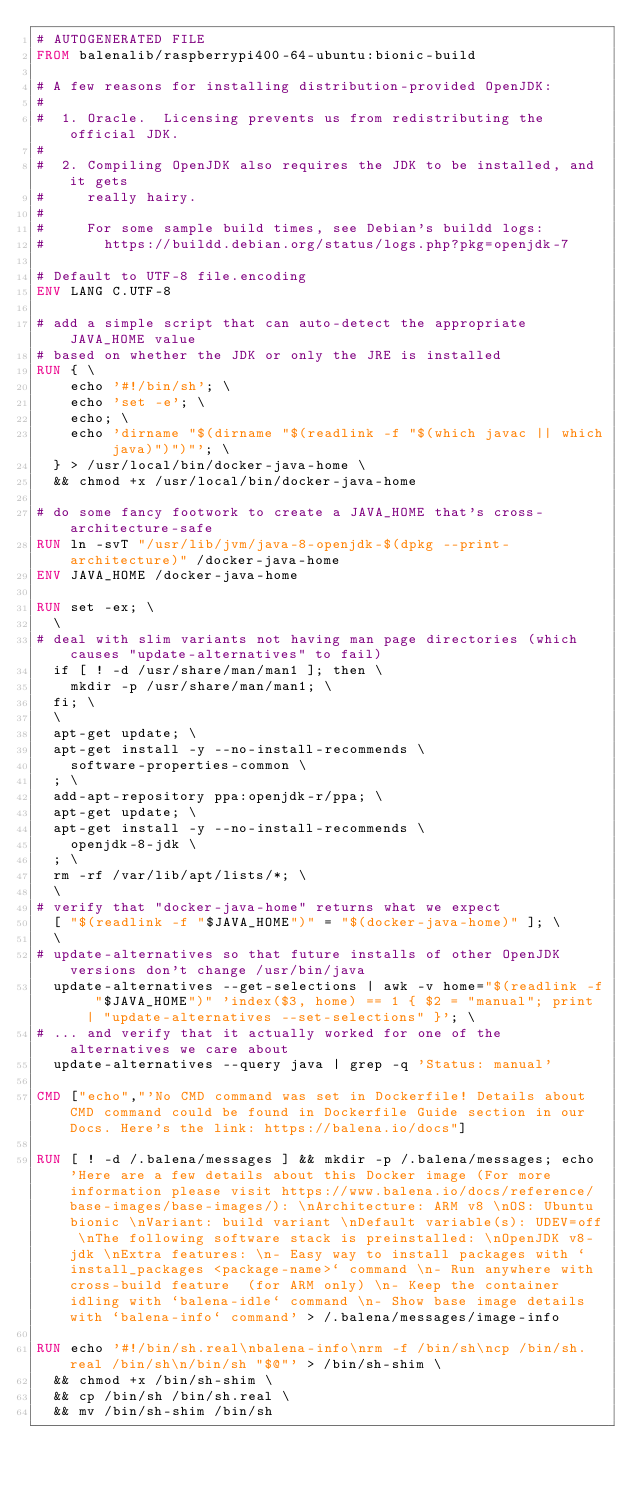<code> <loc_0><loc_0><loc_500><loc_500><_Dockerfile_># AUTOGENERATED FILE
FROM balenalib/raspberrypi400-64-ubuntu:bionic-build

# A few reasons for installing distribution-provided OpenJDK:
#
#  1. Oracle.  Licensing prevents us from redistributing the official JDK.
#
#  2. Compiling OpenJDK also requires the JDK to be installed, and it gets
#     really hairy.
#
#     For some sample build times, see Debian's buildd logs:
#       https://buildd.debian.org/status/logs.php?pkg=openjdk-7

# Default to UTF-8 file.encoding
ENV LANG C.UTF-8

# add a simple script that can auto-detect the appropriate JAVA_HOME value
# based on whether the JDK or only the JRE is installed
RUN { \
		echo '#!/bin/sh'; \
		echo 'set -e'; \
		echo; \
		echo 'dirname "$(dirname "$(readlink -f "$(which javac || which java)")")"'; \
	} > /usr/local/bin/docker-java-home \
	&& chmod +x /usr/local/bin/docker-java-home

# do some fancy footwork to create a JAVA_HOME that's cross-architecture-safe
RUN ln -svT "/usr/lib/jvm/java-8-openjdk-$(dpkg --print-architecture)" /docker-java-home
ENV JAVA_HOME /docker-java-home

RUN set -ex; \
	\
# deal with slim variants not having man page directories (which causes "update-alternatives" to fail)
	if [ ! -d /usr/share/man/man1 ]; then \
		mkdir -p /usr/share/man/man1; \
	fi; \
	\
	apt-get update; \
	apt-get install -y --no-install-recommends \
		software-properties-common \
	; \
	add-apt-repository ppa:openjdk-r/ppa; \
	apt-get update; \
	apt-get install -y --no-install-recommends \
		openjdk-8-jdk \
	; \
	rm -rf /var/lib/apt/lists/*; \
	\
# verify that "docker-java-home" returns what we expect
	[ "$(readlink -f "$JAVA_HOME")" = "$(docker-java-home)" ]; \
	\
# update-alternatives so that future installs of other OpenJDK versions don't change /usr/bin/java
	update-alternatives --get-selections | awk -v home="$(readlink -f "$JAVA_HOME")" 'index($3, home) == 1 { $2 = "manual"; print | "update-alternatives --set-selections" }'; \
# ... and verify that it actually worked for one of the alternatives we care about
	update-alternatives --query java | grep -q 'Status: manual'

CMD ["echo","'No CMD command was set in Dockerfile! Details about CMD command could be found in Dockerfile Guide section in our Docs. Here's the link: https://balena.io/docs"]

RUN [ ! -d /.balena/messages ] && mkdir -p /.balena/messages; echo 'Here are a few details about this Docker image (For more information please visit https://www.balena.io/docs/reference/base-images/base-images/): \nArchitecture: ARM v8 \nOS: Ubuntu bionic \nVariant: build variant \nDefault variable(s): UDEV=off \nThe following software stack is preinstalled: \nOpenJDK v8-jdk \nExtra features: \n- Easy way to install packages with `install_packages <package-name>` command \n- Run anywhere with cross-build feature  (for ARM only) \n- Keep the container idling with `balena-idle` command \n- Show base image details with `balena-info` command' > /.balena/messages/image-info

RUN echo '#!/bin/sh.real\nbalena-info\nrm -f /bin/sh\ncp /bin/sh.real /bin/sh\n/bin/sh "$@"' > /bin/sh-shim \
	&& chmod +x /bin/sh-shim \
	&& cp /bin/sh /bin/sh.real \
	&& mv /bin/sh-shim /bin/sh</code> 